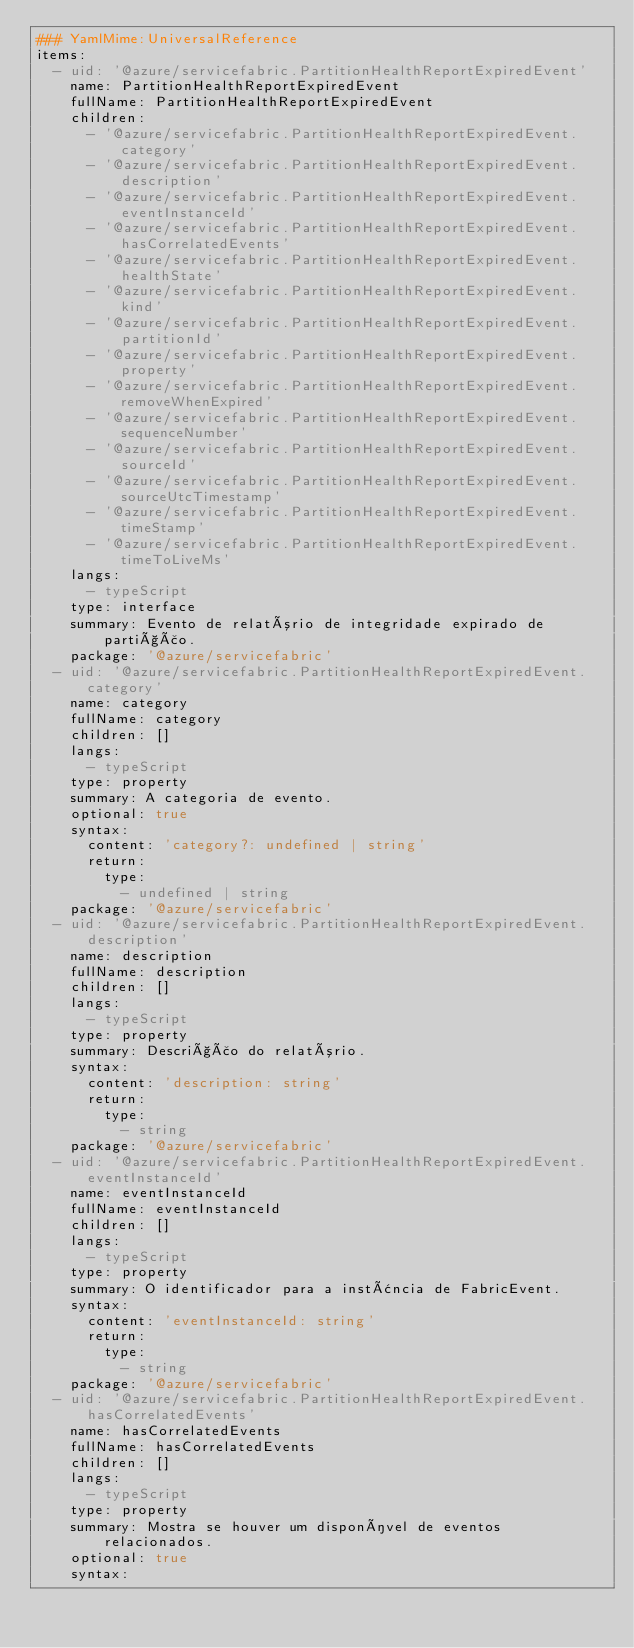<code> <loc_0><loc_0><loc_500><loc_500><_YAML_>### YamlMime:UniversalReference
items:
  - uid: '@azure/servicefabric.PartitionHealthReportExpiredEvent'
    name: PartitionHealthReportExpiredEvent
    fullName: PartitionHealthReportExpiredEvent
    children:
      - '@azure/servicefabric.PartitionHealthReportExpiredEvent.category'
      - '@azure/servicefabric.PartitionHealthReportExpiredEvent.description'
      - '@azure/servicefabric.PartitionHealthReportExpiredEvent.eventInstanceId'
      - '@azure/servicefabric.PartitionHealthReportExpiredEvent.hasCorrelatedEvents'
      - '@azure/servicefabric.PartitionHealthReportExpiredEvent.healthState'
      - '@azure/servicefabric.PartitionHealthReportExpiredEvent.kind'
      - '@azure/servicefabric.PartitionHealthReportExpiredEvent.partitionId'
      - '@azure/servicefabric.PartitionHealthReportExpiredEvent.property'
      - '@azure/servicefabric.PartitionHealthReportExpiredEvent.removeWhenExpired'
      - '@azure/servicefabric.PartitionHealthReportExpiredEvent.sequenceNumber'
      - '@azure/servicefabric.PartitionHealthReportExpiredEvent.sourceId'
      - '@azure/servicefabric.PartitionHealthReportExpiredEvent.sourceUtcTimestamp'
      - '@azure/servicefabric.PartitionHealthReportExpiredEvent.timeStamp'
      - '@azure/servicefabric.PartitionHealthReportExpiredEvent.timeToLiveMs'
    langs:
      - typeScript
    type: interface
    summary: Evento de relatório de integridade expirado de partição.
    package: '@azure/servicefabric'
  - uid: '@azure/servicefabric.PartitionHealthReportExpiredEvent.category'
    name: category
    fullName: category
    children: []
    langs:
      - typeScript
    type: property
    summary: A categoria de evento.
    optional: true
    syntax:
      content: 'category?: undefined | string'
      return:
        type:
          - undefined | string
    package: '@azure/servicefabric'
  - uid: '@azure/servicefabric.PartitionHealthReportExpiredEvent.description'
    name: description
    fullName: description
    children: []
    langs:
      - typeScript
    type: property
    summary: Descrição do relatório.
    syntax:
      content: 'description: string'
      return:
        type:
          - string
    package: '@azure/servicefabric'
  - uid: '@azure/servicefabric.PartitionHealthReportExpiredEvent.eventInstanceId'
    name: eventInstanceId
    fullName: eventInstanceId
    children: []
    langs:
      - typeScript
    type: property
    summary: O identificador para a instância de FabricEvent.
    syntax:
      content: 'eventInstanceId: string'
      return:
        type:
          - string
    package: '@azure/servicefabric'
  - uid: '@azure/servicefabric.PartitionHealthReportExpiredEvent.hasCorrelatedEvents'
    name: hasCorrelatedEvents
    fullName: hasCorrelatedEvents
    children: []
    langs:
      - typeScript
    type: property
    summary: Mostra se houver um disponível de eventos relacionados.
    optional: true
    syntax:</code> 